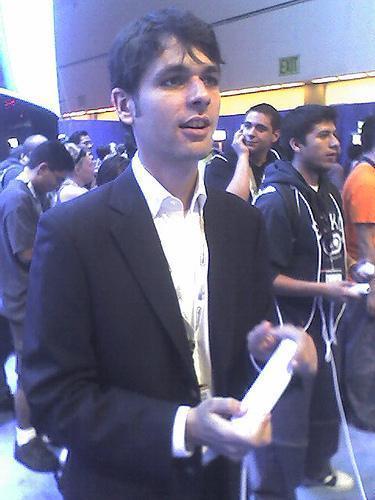How many boys are playing video games?
Give a very brief answer. 2. How many people are in the picture?
Give a very brief answer. 5. 